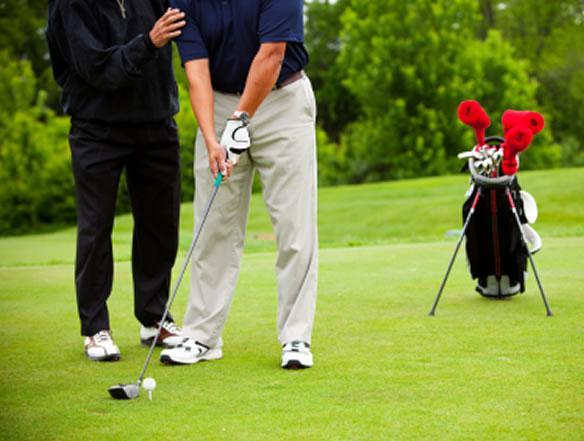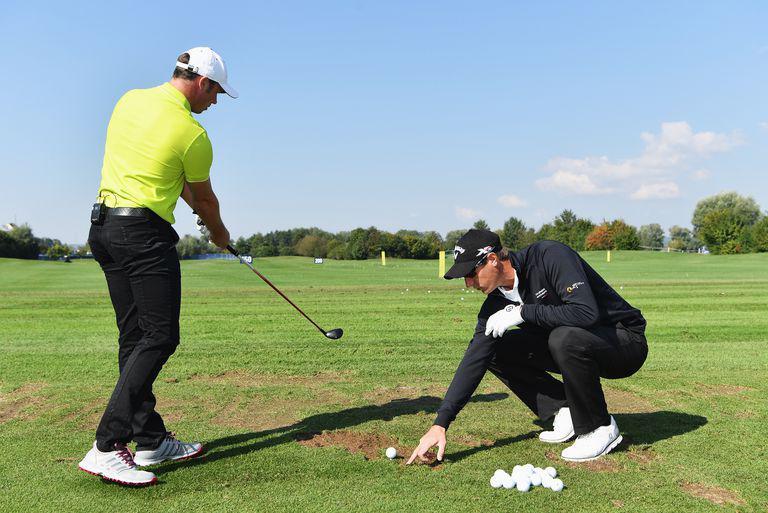The first image is the image on the left, the second image is the image on the right. Examine the images to the left and right. Is the description "The right image shows one man standing and holding a golf club next to a man crouched down beside him on a golf course" accurate? Answer yes or no. Yes. The first image is the image on the left, the second image is the image on the right. Examine the images to the left and right. Is the description "A man crouches in the grass to the right of a man who is standing and swinging a golf club." accurate? Answer yes or no. Yes. 